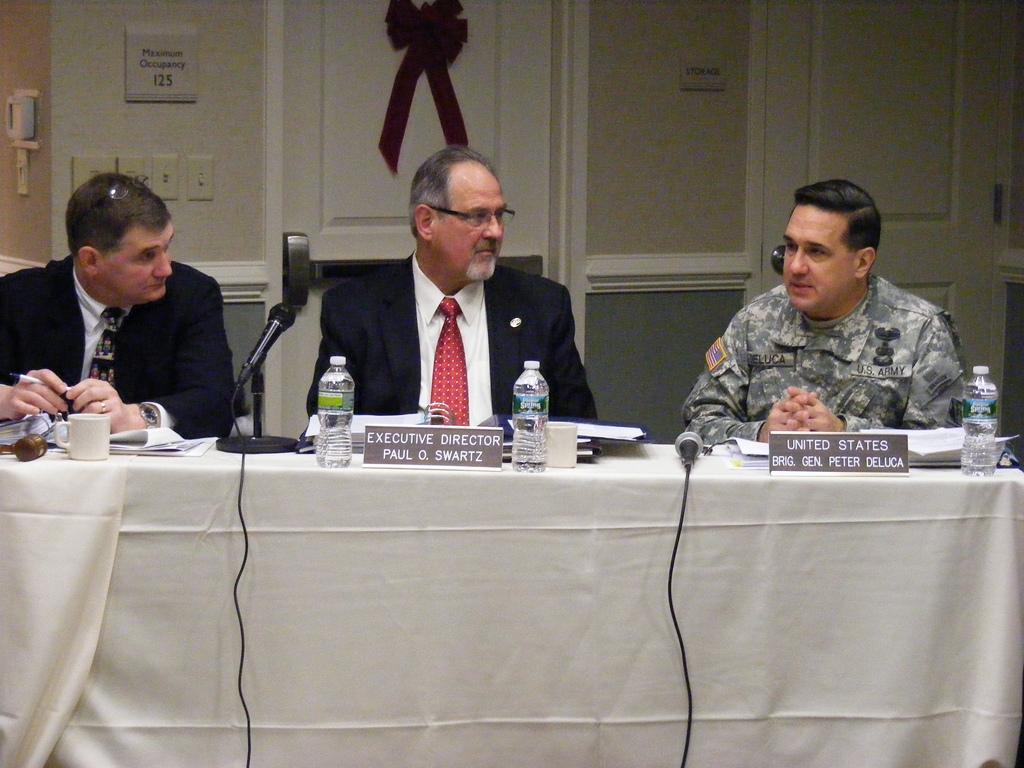How would you summarize this image in a sentence or two? In this image, there are three persons sitting on the chairs. I can see the water bottles, name boards, books, papers, cups and miles on a table. In the background, there are doors, switch boards and a poster attached to the wall. 